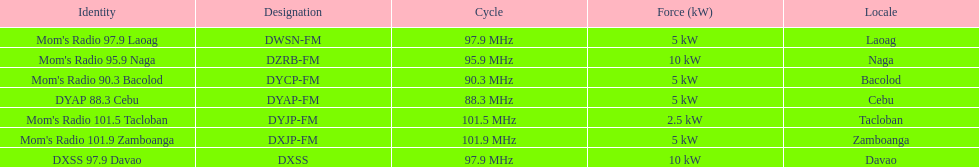What is the total number of stations with frequencies above 100 mhz? 2. 